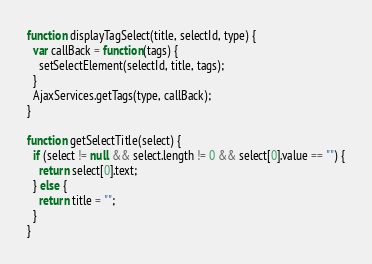<code> <loc_0><loc_0><loc_500><loc_500><_JavaScript_>
function displayTagSelect(title, selectId, type) {
  var callBack = function(tags) {
    setSelectElement(selectId, title, tags);
  }
  AjaxServices.getTags(type, callBack);
}

function getSelectTitle(select) {
  if (select != null && select.length != 0 && select[0].value == "") {
    return select[0].text;
  } else {
    return title = "";
  }
}
</code> 